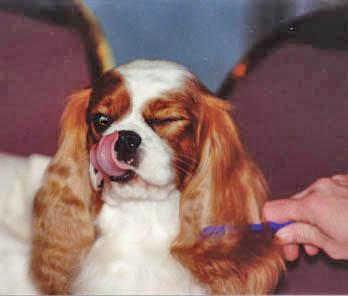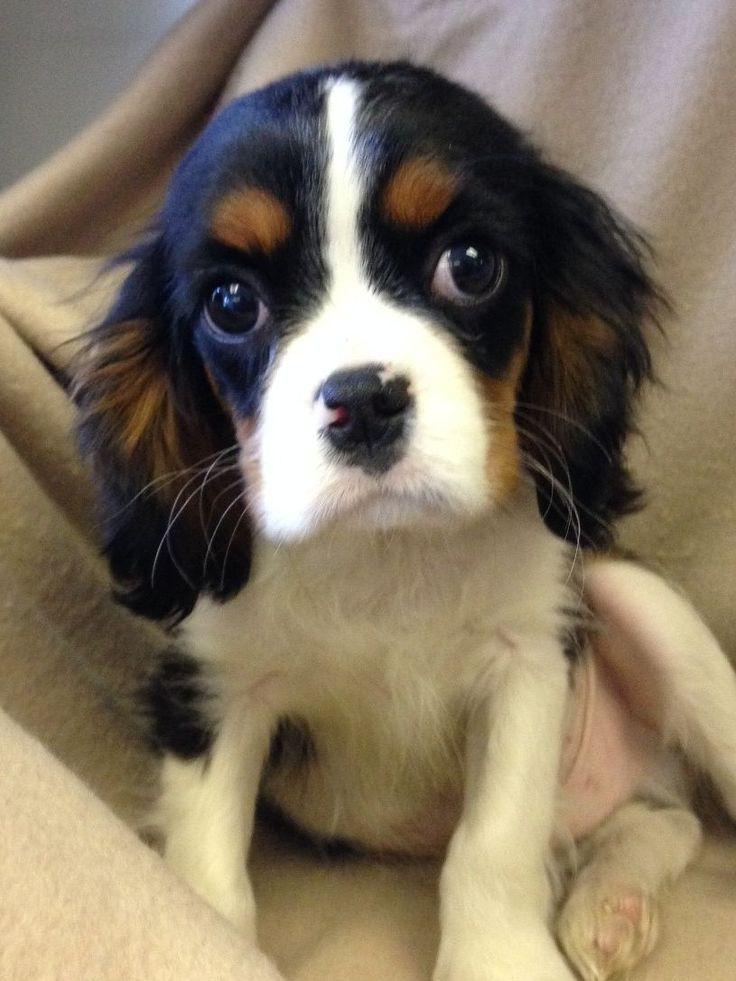The first image is the image on the left, the second image is the image on the right. For the images shown, is this caption "A person is holding up two dogs in the image on the left." true? Answer yes or no. No. The first image is the image on the left, the second image is the image on the right. Assess this claim about the two images: "The right image shows a small brown and white dog with a bow on its head". Correct or not? Answer yes or no. No. 